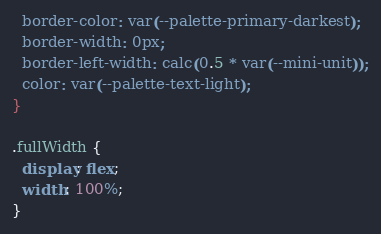Convert code to text. <code><loc_0><loc_0><loc_500><loc_500><_CSS_>  border-color: var(--palette-primary-darkest);
  border-width: 0px;
  border-left-width: calc(0.5 * var(--mini-unit));
  color: var(--palette-text-light);
}

.fullWidth {
  display: flex;
  width: 100%;
}
</code> 